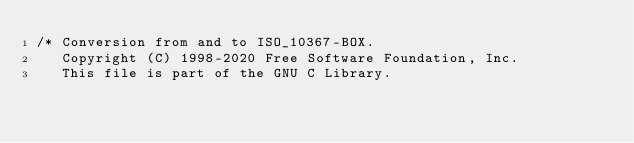Convert code to text. <code><loc_0><loc_0><loc_500><loc_500><_C_>/* Conversion from and to ISO_10367-BOX.
   Copyright (C) 1998-2020 Free Software Foundation, Inc.
   This file is part of the GNU C Library.</code> 